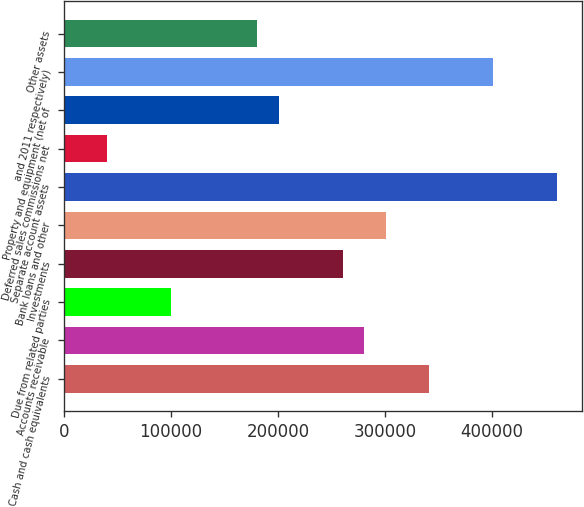Convert chart to OTSL. <chart><loc_0><loc_0><loc_500><loc_500><bar_chart><fcel>Cash and cash equivalents<fcel>Accounts receivable<fcel>Due from related parties<fcel>Investments<fcel>Bank loans and other<fcel>Separate account assets<fcel>Deferred sales commissions net<fcel>Property and equipment (net of<fcel>and 2011 respectively)<fcel>Other assets<nl><fcel>340765<fcel>280631<fcel>100226<fcel>260586<fcel>300676<fcel>461035<fcel>40091.8<fcel>200451<fcel>400900<fcel>180406<nl></chart> 